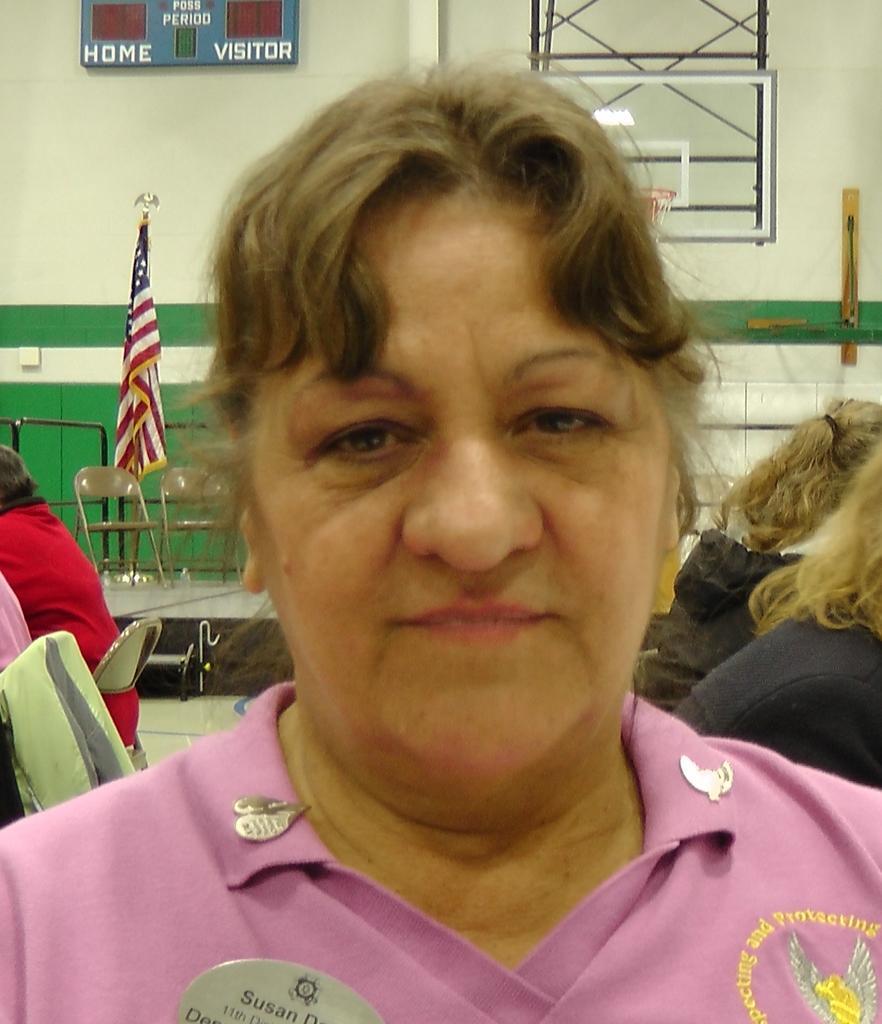Could you give a brief overview of what you see in this image? A picture of a women who is in pink color shirt and also behind her there is a flag and some people sitting behind her on the chairs. 